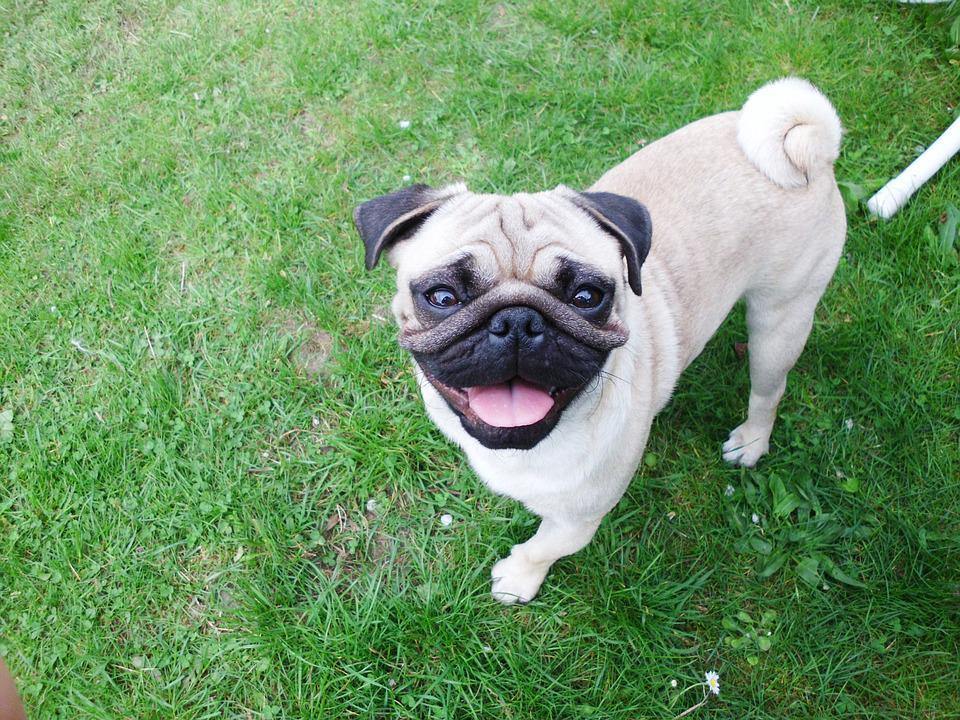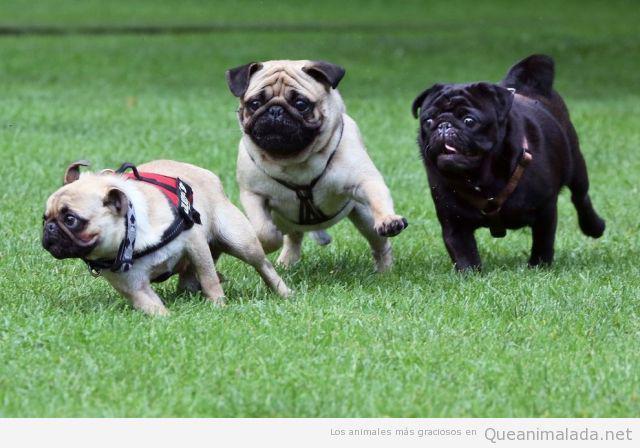The first image is the image on the left, the second image is the image on the right. Considering the images on both sides, is "There are at least four pugs in total." valid? Answer yes or no. Yes. The first image is the image on the left, the second image is the image on the right. Examine the images to the left and right. Is the description "there is at least one dog in the image pair running and none of it's feet are touching the ground" accurate? Answer yes or no. No. 